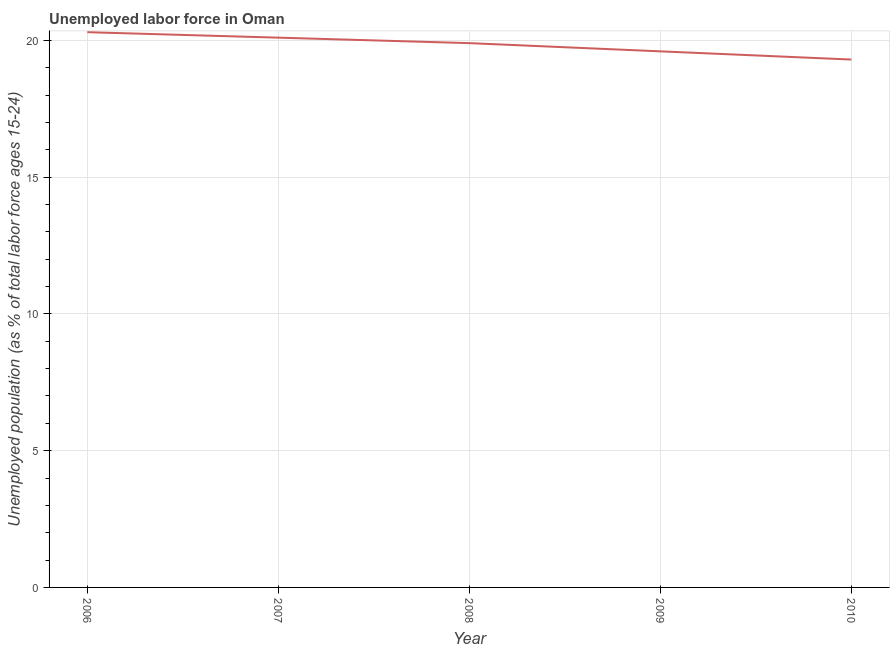What is the total unemployed youth population in 2007?
Offer a very short reply. 20.1. Across all years, what is the maximum total unemployed youth population?
Your response must be concise. 20.3. Across all years, what is the minimum total unemployed youth population?
Make the answer very short. 19.3. What is the sum of the total unemployed youth population?
Provide a succinct answer. 99.2. What is the difference between the total unemployed youth population in 2006 and 2009?
Your answer should be very brief. 0.7. What is the average total unemployed youth population per year?
Your answer should be compact. 19.84. What is the median total unemployed youth population?
Your answer should be compact. 19.9. In how many years, is the total unemployed youth population greater than 10 %?
Offer a very short reply. 5. Do a majority of the years between 2009 and 2008 (inclusive) have total unemployed youth population greater than 15 %?
Your response must be concise. No. What is the ratio of the total unemployed youth population in 2006 to that in 2007?
Make the answer very short. 1.01. Is the total unemployed youth population in 2006 less than that in 2009?
Keep it short and to the point. No. What is the difference between the highest and the second highest total unemployed youth population?
Ensure brevity in your answer.  0.2. How many lines are there?
Make the answer very short. 1. What is the difference between two consecutive major ticks on the Y-axis?
Provide a succinct answer. 5. What is the title of the graph?
Provide a short and direct response. Unemployed labor force in Oman. What is the label or title of the X-axis?
Give a very brief answer. Year. What is the label or title of the Y-axis?
Provide a short and direct response. Unemployed population (as % of total labor force ages 15-24). What is the Unemployed population (as % of total labor force ages 15-24) of 2006?
Your answer should be compact. 20.3. What is the Unemployed population (as % of total labor force ages 15-24) of 2007?
Provide a succinct answer. 20.1. What is the Unemployed population (as % of total labor force ages 15-24) of 2008?
Provide a succinct answer. 19.9. What is the Unemployed population (as % of total labor force ages 15-24) in 2009?
Provide a succinct answer. 19.6. What is the Unemployed population (as % of total labor force ages 15-24) of 2010?
Your answer should be compact. 19.3. What is the difference between the Unemployed population (as % of total labor force ages 15-24) in 2006 and 2010?
Make the answer very short. 1. What is the difference between the Unemployed population (as % of total labor force ages 15-24) in 2007 and 2008?
Your answer should be very brief. 0.2. What is the difference between the Unemployed population (as % of total labor force ages 15-24) in 2007 and 2009?
Your answer should be compact. 0.5. What is the difference between the Unemployed population (as % of total labor force ages 15-24) in 2007 and 2010?
Ensure brevity in your answer.  0.8. What is the difference between the Unemployed population (as % of total labor force ages 15-24) in 2009 and 2010?
Your response must be concise. 0.3. What is the ratio of the Unemployed population (as % of total labor force ages 15-24) in 2006 to that in 2009?
Keep it short and to the point. 1.04. What is the ratio of the Unemployed population (as % of total labor force ages 15-24) in 2006 to that in 2010?
Ensure brevity in your answer.  1.05. What is the ratio of the Unemployed population (as % of total labor force ages 15-24) in 2007 to that in 2008?
Give a very brief answer. 1.01. What is the ratio of the Unemployed population (as % of total labor force ages 15-24) in 2007 to that in 2009?
Offer a very short reply. 1.03. What is the ratio of the Unemployed population (as % of total labor force ages 15-24) in 2007 to that in 2010?
Keep it short and to the point. 1.04. What is the ratio of the Unemployed population (as % of total labor force ages 15-24) in 2008 to that in 2009?
Your answer should be very brief. 1.01. What is the ratio of the Unemployed population (as % of total labor force ages 15-24) in 2008 to that in 2010?
Make the answer very short. 1.03. What is the ratio of the Unemployed population (as % of total labor force ages 15-24) in 2009 to that in 2010?
Make the answer very short. 1.02. 